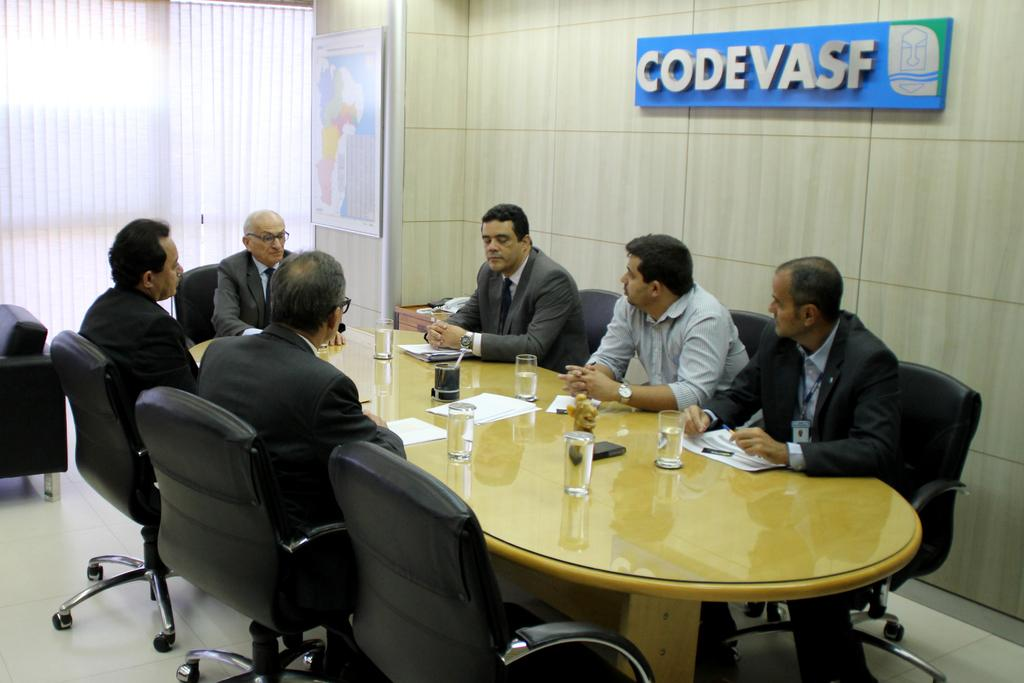Provide a one-sentence caption for the provided image. A group of men sitting around the table with a sign that says "CodeVasf" above there heats. 